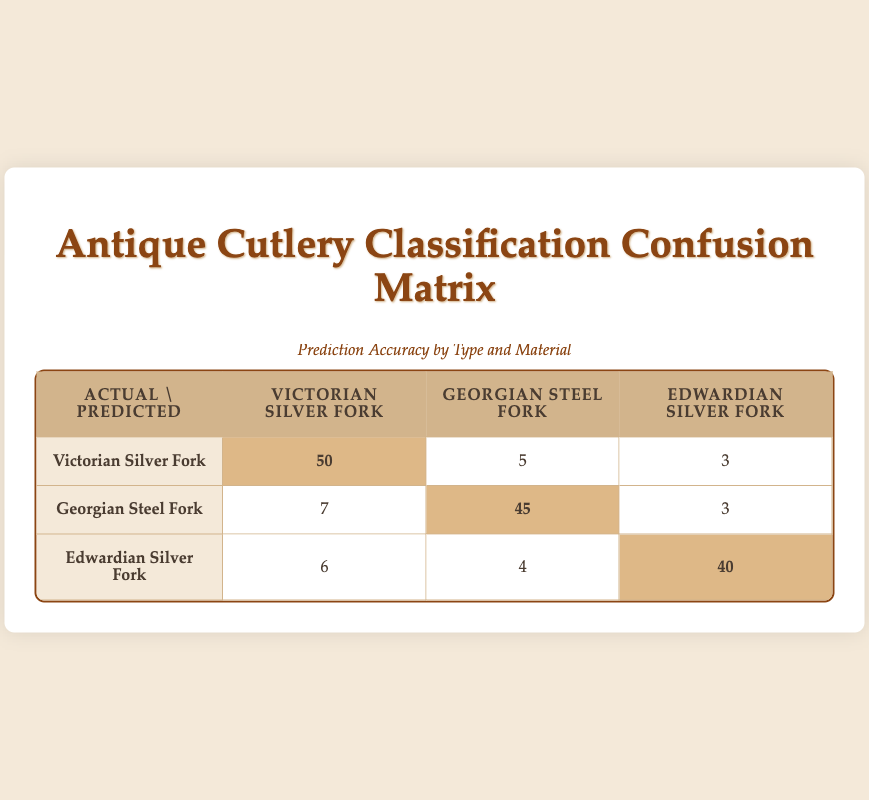What is the predicted accuracy for the Victorian Silver Fork? The table shows that the actual and predicted counts for the Victorian Silver Fork are 50 when correctly identified, 5 for Georgian Steel Fork, and 3 for Edwardian Silver Fork. Therefore, the predicted accuracy for the Victorian Silver Fork is represented by the highlight of 50.
Answer: 50 How many Georgian Steel Forks were correctly identified? Looking at the Georgian Steel Fork row, the predicted values show a highlight of 45 for the correctly identified Georgian Steel Fork, which indicates its predicted accuracy.
Answer: 45 What is the total number of predictions for Edwardian Silver Fork? To find the total number of predictions for Edwardian Silver Fork, we add the counts from its row: 6 (Victorian Silver Fork), 4 (Georgian Steel Fork), and 40 (Edwardian Silver Fork), which totals 6 + 4 + 40 = 50.
Answer: 50 Is it true that more Victorian Silver Forks were misclassified than Georgian Steel Forks? In the table, Victorian Silver Fork misclassifications show a sum of 5 (as Georgian Steel Fork) plus 3 (as Edwardian Silver Fork), totaling 8 misclassifications. For Georgian Steel Fork, the misclassification counts are 7 (as Victorian Silver Fork) plus 3 (as Edwardian Silver Fork), totaling 10 misclassifications. Since 8 < 10, the statement is false.
Answer: No What percentage of Georgian Steel Forks were correctly classified? The number of correctly classified Georgian Steel Forks is 45, while the total is the sum of all predictions for Georgian Steel Fork (45 + 7 + 3 = 55). The percentage is (45/55) * 100 = 81.82%.
Answer: 81.82% What is the overall classification accuracy for all types combined? To calculate the overall classification accuracy, we sum up the correctly classified items (50 + 45 + 40 = 135) and divide it by the total number of predictions, which is 50 + 5 + 3 + 7 + 45 + 3 + 6 + 4 + 40 = 164. The accuracy is (135/164) * 100 = 82.32%.
Answer: 82.32% How many Edwardian Silver Forks were predicted incorrectly? Looking at the row for Edwardian Silver Fork, the counts for misclassification include 6 (as Victorian Silver Fork) and 4 (as Georgian Steel Fork), totaling 10 mispredicted Edwardian Silver Forks.
Answer: 10 Which type of fork has the highest total misclassification rates? To assess this, we need to tally the misclassifications for each type: Victorian Silver Fork has 5 + 3 = 8, Georgian Steel Fork has 7 + 3 = 10, and Edwardian Silver Fork has 10 (6 + 4). The highest total misclassification rate is for Edwardian Silver Fork with 10 misclassifications.
Answer: Edwardian Silver Fork 